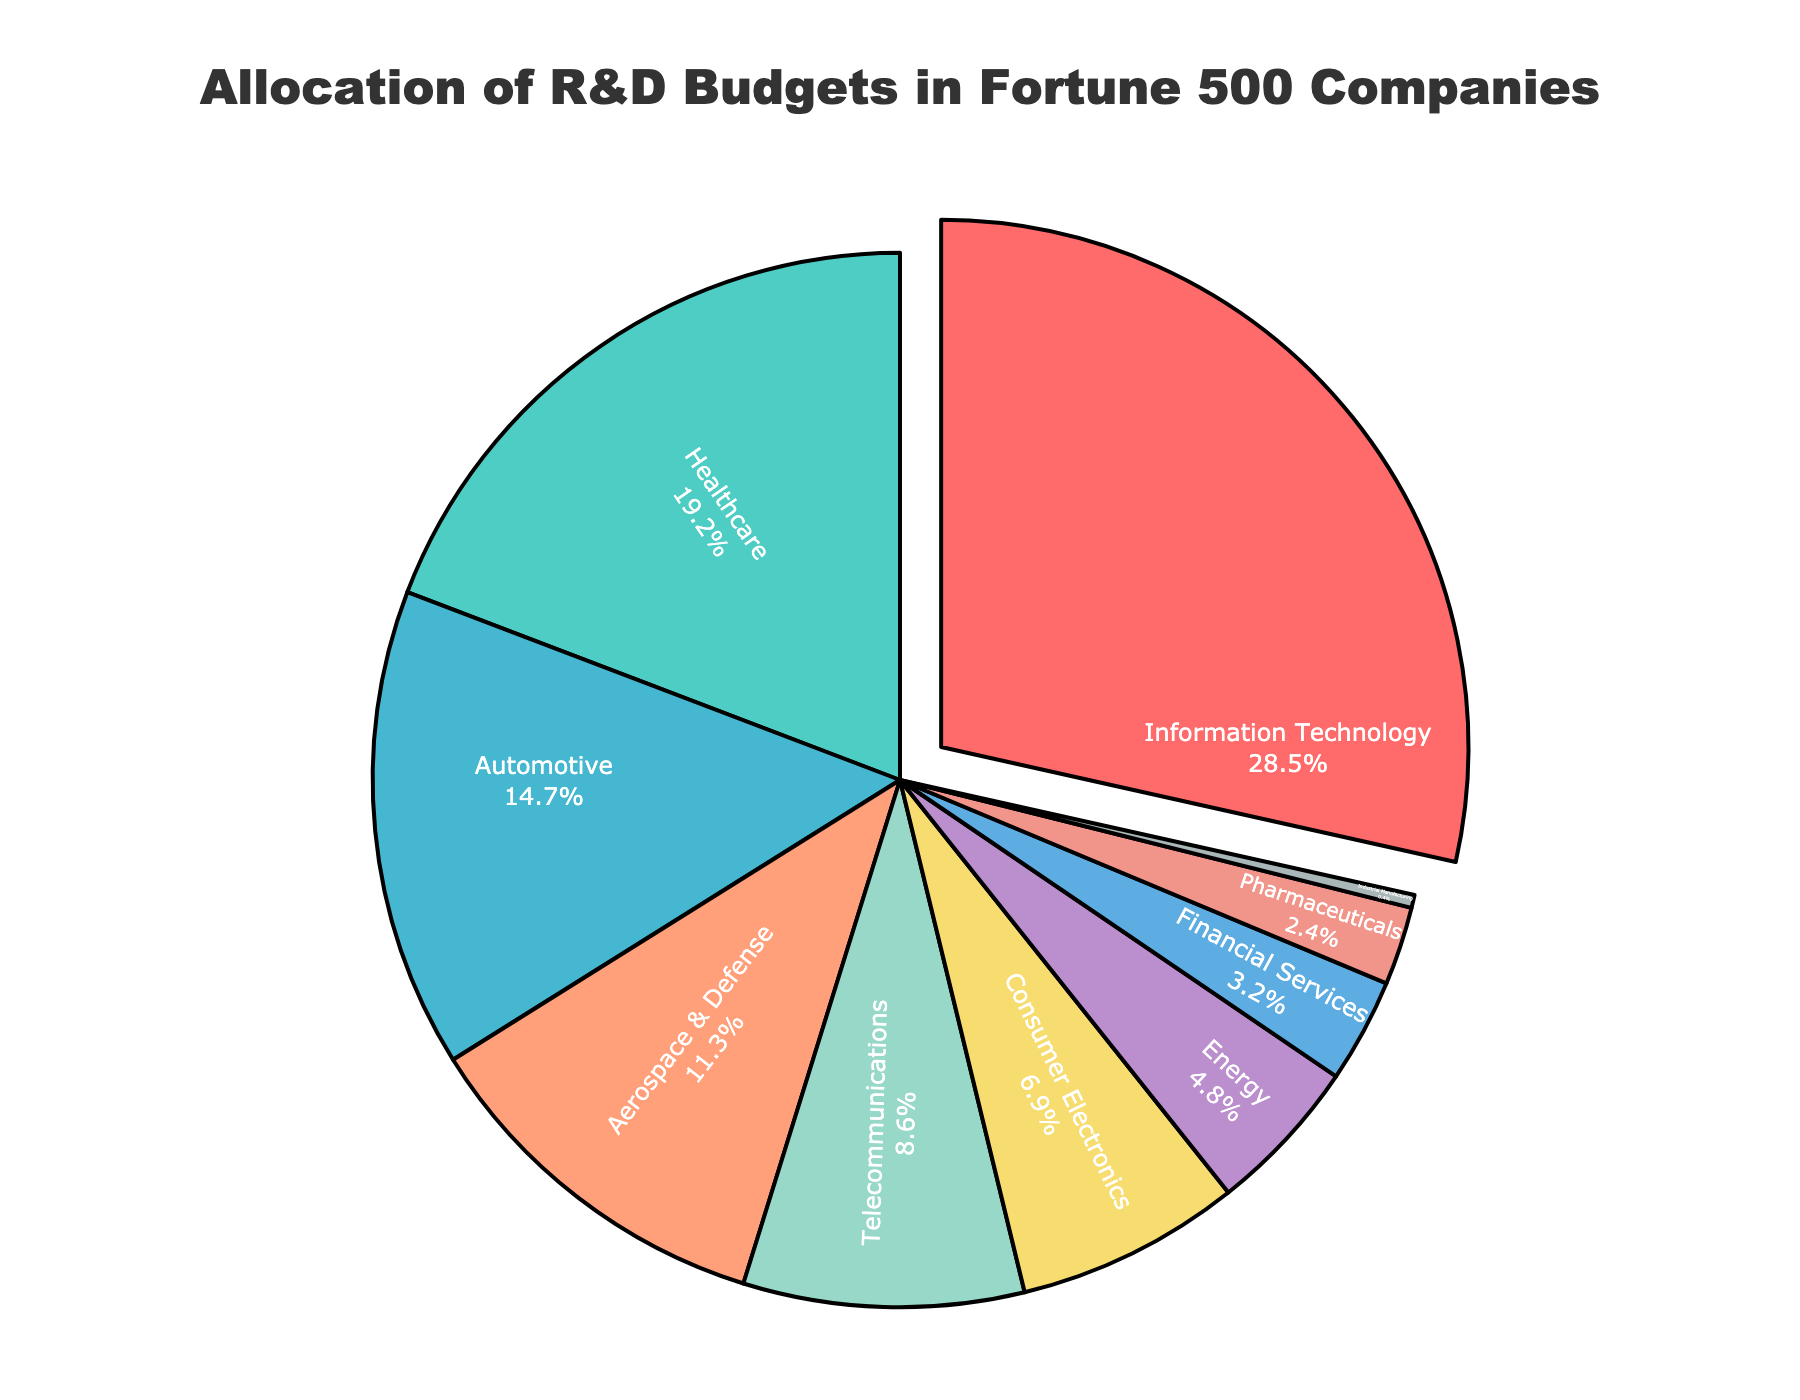what is the total percentage allocated to the top three sectors? Sum the percentages of the top three sectors: Information Technology (28.5%), Healthcare (19.2%), and Automotive (14.7%): 28.5 + 19.2 + 14.7 = 62.4
Answer: 62.4 which sector has the smallest allocation, and what is its percentage? Identify the sector with the smallest percentage: Industrial Manufacturing with 0.4%
Answer: Industrial Manufacturing, 0.4% Is the allocation for Healthcare greater than that for Telecommunications plus Energy? Compare the percentages: Healthcare (19.2%) and Telecommunications plus Energy (8.6% + 4.8% = 13.4%). Since 19.2% > 13.4%, Healthcare has a greater allocation.
Answer: Yes, Healthcare has a greater allocation What is the difference between the allocations of Information Technology and Pharmaceuticals? Subtract the percentage of Pharmaceuticals (2.4%) from Information Technology (28.5%): 28.5 - 2.4 = 26.1
Answer: 26.1 Which sectors combined equal more than half the total allocation and what are their percentages? Identify sectors whose percentages add up to more than 50%. Information Technology (28.5%) and Healthcare (19.2%) together: 28.5 + 19.2 = 47.7, adding Automotive (14.7%): 47.7 + 14.7 = 62.4. These sectors are Information Technology, Healthcare, and Automotive with a combined total of 62.4%
Answer: Information Technology, Healthcare, Automotive; 62.4 What is the color representing Automotive in the pie chart? Based on visual identification, Automotive is represented by the third color in the series which is blue
Answer: Blue(debug), deep pink (live) How does the allocation of Aerospace & Defense compare to that of Consumer Electronics? Compare the percentages for each sector: Aerospace & Defense (11.3%) and Consumer Electronics (6.9%). Since 11.3% > 6.9%, Aerospace & Defense has a higher allocation.
Answer: Aerospace & Defense has a higher allocation What is the combined percentage allocation of the sectors with less than 5%? Identify sectors with less than 5% and sum their percentages: Energy (4.8%), Financial Services (3.2%), Pharmaceuticals (2.4%), and Industrial Manufacturing (0.4%). Summing these: 4.8 + 3.2 + 2.4 + 0.4 = 10.8
Answer: 10.8 Which sector's allocation is closest to 7% and what is the exact allocation? Identify the sector with a percentage closest to 7%: Consumer Electronics with a percentage of 6.9%
Answer: Consumer Electronics, 6.9 What percentage of R&D budgets is allocated to sectors not in the top 5? Sum the percentages of sectors not in the top 5: Consumer Electronics (6.9%), Energy (4.8%), Financial Services (3.2%), Pharmaceuticals (2.4%), and Industrial Manufacturing (0.4%). Adding these gives: 6.9 + 4.8 + 3.2 + 2.4 + 0.4 = 17.7
Answer: 17.7 